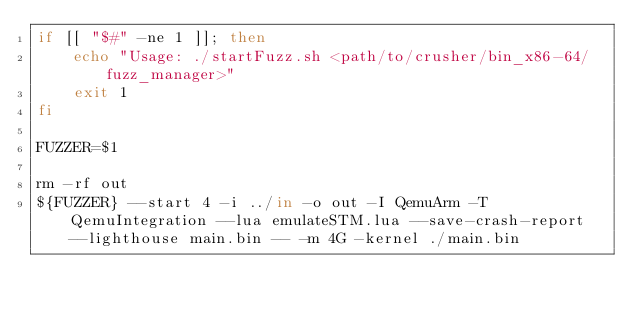<code> <loc_0><loc_0><loc_500><loc_500><_Bash_>if [[ "$#" -ne 1 ]]; then
    echo "Usage: ./startFuzz.sh <path/to/crusher/bin_x86-64/fuzz_manager>"
    exit 1
fi

FUZZER=$1

rm -rf out
${FUZZER} --start 4 -i ../in -o out -I QemuArm -T QemuIntegration --lua emulateSTM.lua --save-crash-report --lighthouse main.bin -- -m 4G -kernel ./main.bin
</code> 